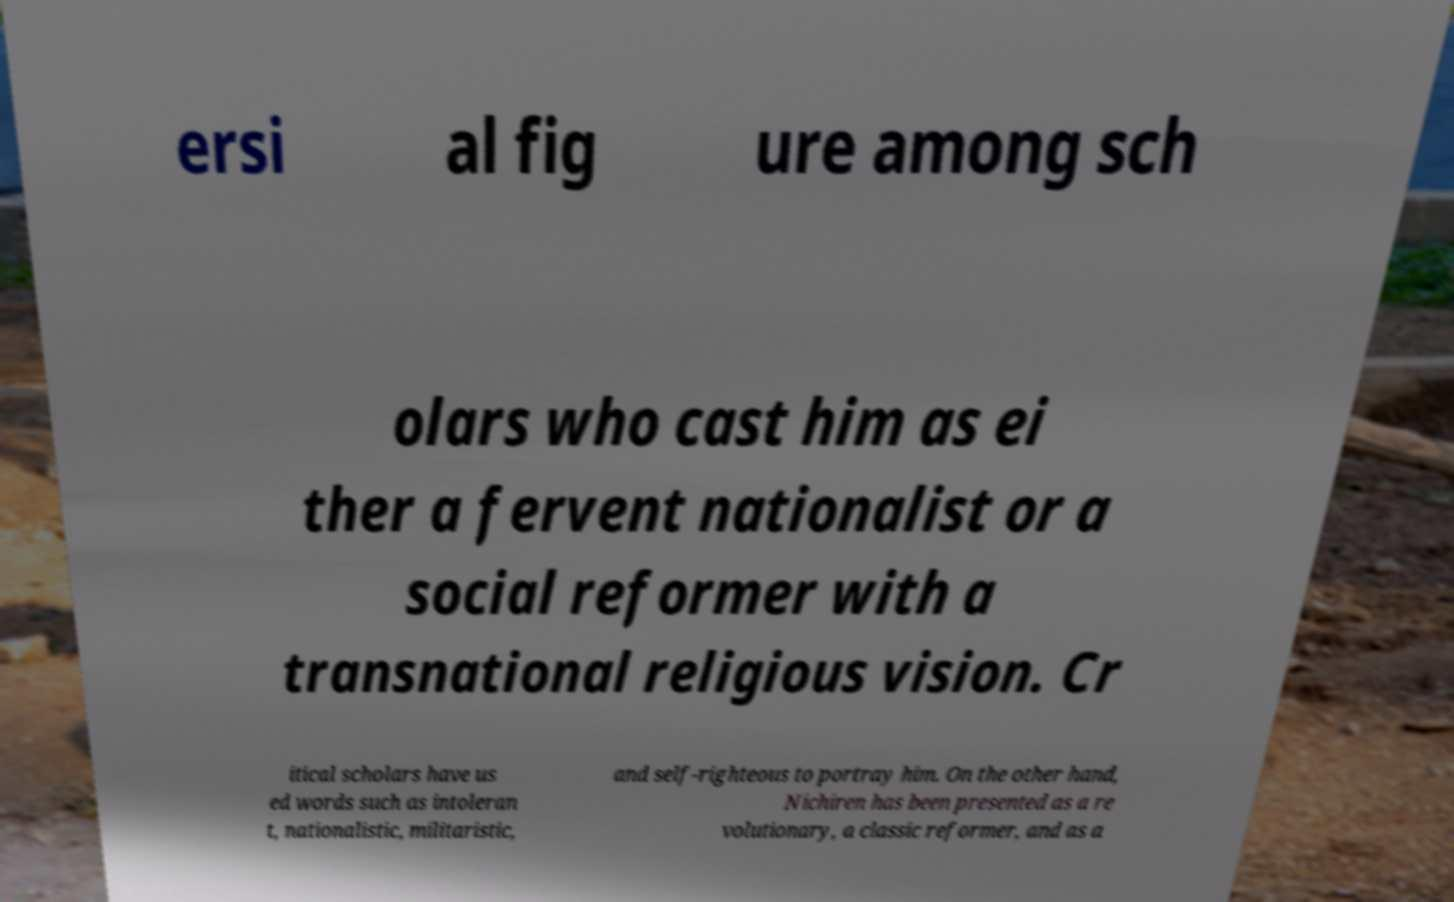Could you assist in decoding the text presented in this image and type it out clearly? ersi al fig ure among sch olars who cast him as ei ther a fervent nationalist or a social reformer with a transnational religious vision. Cr itical scholars have us ed words such as intoleran t, nationalistic, militaristic, and self-righteous to portray him. On the other hand, Nichiren has been presented as a re volutionary, a classic reformer, and as a 